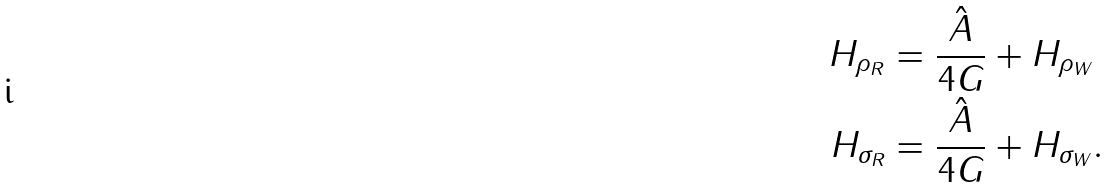Convert formula to latex. <formula><loc_0><loc_0><loc_500><loc_500>H _ { \rho _ { R } } & = \frac { \hat { A } } { 4 G } + H _ { \rho _ { W } } \\ H _ { \sigma _ { R } } & = \frac { \hat { A } } { 4 G } + H _ { \sigma _ { W } } .</formula> 